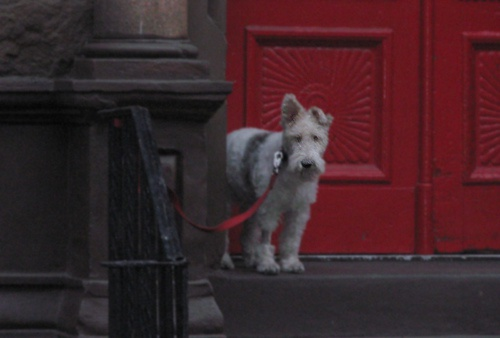Describe the objects in this image and their specific colors. I can see a dog in black, gray, and maroon tones in this image. 